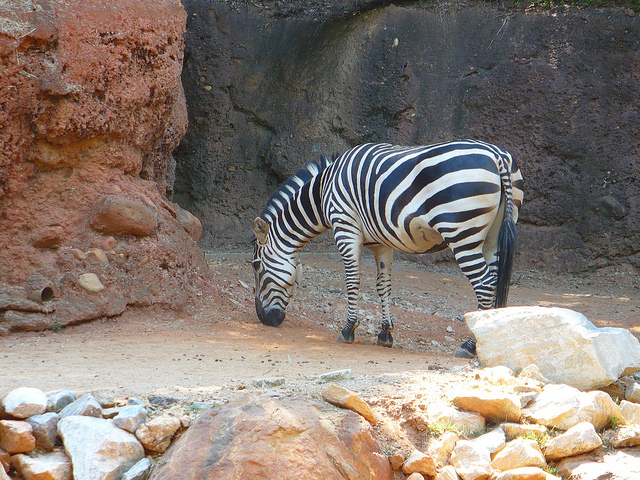<image>What is unnatural about this animal's setting? It is unknown what is unnatural about this animal's setting. The animal could potentially be in a zoo or a rocky, grassless area. What is unnatural about this animal's setting? It is ambiguous what is unnatural about this animal's setting. It can be seen that there are rocks and no grass. 